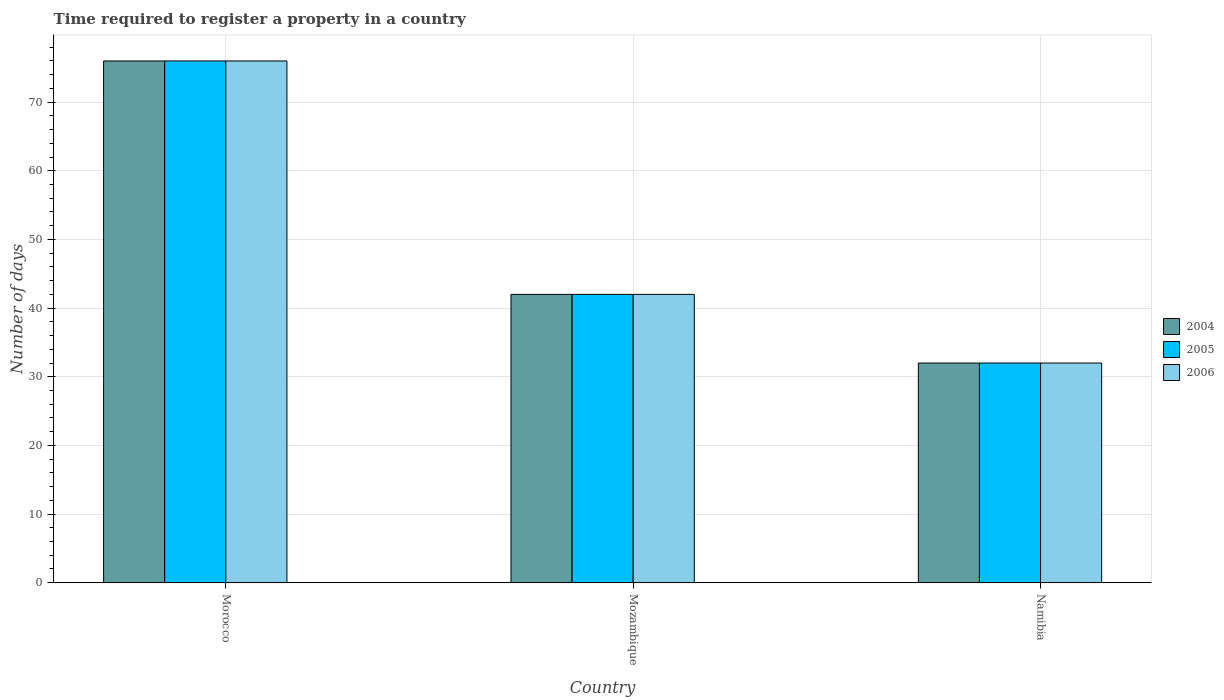How many different coloured bars are there?
Make the answer very short. 3. How many groups of bars are there?
Give a very brief answer. 3. How many bars are there on the 3rd tick from the left?
Keep it short and to the point. 3. What is the label of the 3rd group of bars from the left?
Keep it short and to the point. Namibia. In how many cases, is the number of bars for a given country not equal to the number of legend labels?
Provide a succinct answer. 0. What is the number of days required to register a property in 2004 in Namibia?
Offer a very short reply. 32. Across all countries, what is the maximum number of days required to register a property in 2006?
Your answer should be compact. 76. Across all countries, what is the minimum number of days required to register a property in 2006?
Give a very brief answer. 32. In which country was the number of days required to register a property in 2005 maximum?
Keep it short and to the point. Morocco. In which country was the number of days required to register a property in 2006 minimum?
Keep it short and to the point. Namibia. What is the total number of days required to register a property in 2006 in the graph?
Give a very brief answer. 150. What is the difference between the number of days required to register a property in 2006 in Namibia and the number of days required to register a property in 2004 in Morocco?
Your answer should be very brief. -44. What is the average number of days required to register a property in 2004 per country?
Make the answer very short. 50. In how many countries, is the number of days required to register a property in 2006 greater than 28 days?
Ensure brevity in your answer.  3. What is the ratio of the number of days required to register a property in 2005 in Morocco to that in Namibia?
Give a very brief answer. 2.38. Is the difference between the number of days required to register a property in 2006 in Morocco and Namibia greater than the difference between the number of days required to register a property in 2005 in Morocco and Namibia?
Your answer should be compact. No. What does the 3rd bar from the left in Morocco represents?
Provide a succinct answer. 2006. What does the 2nd bar from the right in Namibia represents?
Your answer should be compact. 2005. How many bars are there?
Offer a very short reply. 9. Are all the bars in the graph horizontal?
Offer a very short reply. No. How many countries are there in the graph?
Your response must be concise. 3. What is the difference between two consecutive major ticks on the Y-axis?
Provide a succinct answer. 10. Does the graph contain any zero values?
Ensure brevity in your answer.  No. Does the graph contain grids?
Keep it short and to the point. Yes. How many legend labels are there?
Your answer should be compact. 3. How are the legend labels stacked?
Offer a terse response. Vertical. What is the title of the graph?
Ensure brevity in your answer.  Time required to register a property in a country. Does "2006" appear as one of the legend labels in the graph?
Ensure brevity in your answer.  Yes. What is the label or title of the X-axis?
Keep it short and to the point. Country. What is the label or title of the Y-axis?
Provide a succinct answer. Number of days. What is the Number of days in 2004 in Morocco?
Your answer should be very brief. 76. What is the Number of days of 2005 in Morocco?
Your answer should be compact. 76. What is the Number of days of 2006 in Morocco?
Your answer should be very brief. 76. What is the Number of days of 2004 in Mozambique?
Ensure brevity in your answer.  42. What is the Number of days of 2005 in Mozambique?
Your response must be concise. 42. What is the Number of days of 2006 in Mozambique?
Provide a short and direct response. 42. What is the Number of days in 2006 in Namibia?
Offer a terse response. 32. Across all countries, what is the maximum Number of days of 2004?
Your answer should be very brief. 76. Across all countries, what is the maximum Number of days of 2005?
Ensure brevity in your answer.  76. What is the total Number of days in 2004 in the graph?
Keep it short and to the point. 150. What is the total Number of days of 2005 in the graph?
Keep it short and to the point. 150. What is the total Number of days of 2006 in the graph?
Keep it short and to the point. 150. What is the difference between the Number of days of 2006 in Morocco and that in Mozambique?
Provide a succinct answer. 34. What is the difference between the Number of days of 2004 in Morocco and that in Namibia?
Offer a terse response. 44. What is the difference between the Number of days in 2006 in Morocco and that in Namibia?
Offer a very short reply. 44. What is the difference between the Number of days in 2006 in Mozambique and that in Namibia?
Give a very brief answer. 10. What is the difference between the Number of days of 2004 in Morocco and the Number of days of 2005 in Mozambique?
Your response must be concise. 34. What is the difference between the Number of days in 2004 in Morocco and the Number of days in 2006 in Mozambique?
Your answer should be very brief. 34. What is the difference between the Number of days in 2005 in Mozambique and the Number of days in 2006 in Namibia?
Give a very brief answer. 10. What is the difference between the Number of days in 2004 and Number of days in 2005 in Morocco?
Your response must be concise. 0. What is the difference between the Number of days in 2005 and Number of days in 2006 in Morocco?
Offer a very short reply. 0. What is the difference between the Number of days of 2004 and Number of days of 2005 in Mozambique?
Offer a very short reply. 0. What is the difference between the Number of days of 2005 and Number of days of 2006 in Mozambique?
Give a very brief answer. 0. What is the difference between the Number of days of 2004 and Number of days of 2005 in Namibia?
Your answer should be compact. 0. What is the difference between the Number of days in 2004 and Number of days in 2006 in Namibia?
Offer a terse response. 0. What is the ratio of the Number of days in 2004 in Morocco to that in Mozambique?
Offer a very short reply. 1.81. What is the ratio of the Number of days in 2005 in Morocco to that in Mozambique?
Provide a succinct answer. 1.81. What is the ratio of the Number of days of 2006 in Morocco to that in Mozambique?
Keep it short and to the point. 1.81. What is the ratio of the Number of days in 2004 in Morocco to that in Namibia?
Your response must be concise. 2.38. What is the ratio of the Number of days of 2005 in Morocco to that in Namibia?
Your answer should be very brief. 2.38. What is the ratio of the Number of days of 2006 in Morocco to that in Namibia?
Your answer should be compact. 2.38. What is the ratio of the Number of days in 2004 in Mozambique to that in Namibia?
Make the answer very short. 1.31. What is the ratio of the Number of days of 2005 in Mozambique to that in Namibia?
Offer a very short reply. 1.31. What is the ratio of the Number of days in 2006 in Mozambique to that in Namibia?
Your answer should be very brief. 1.31. What is the difference between the highest and the second highest Number of days of 2005?
Your response must be concise. 34. 